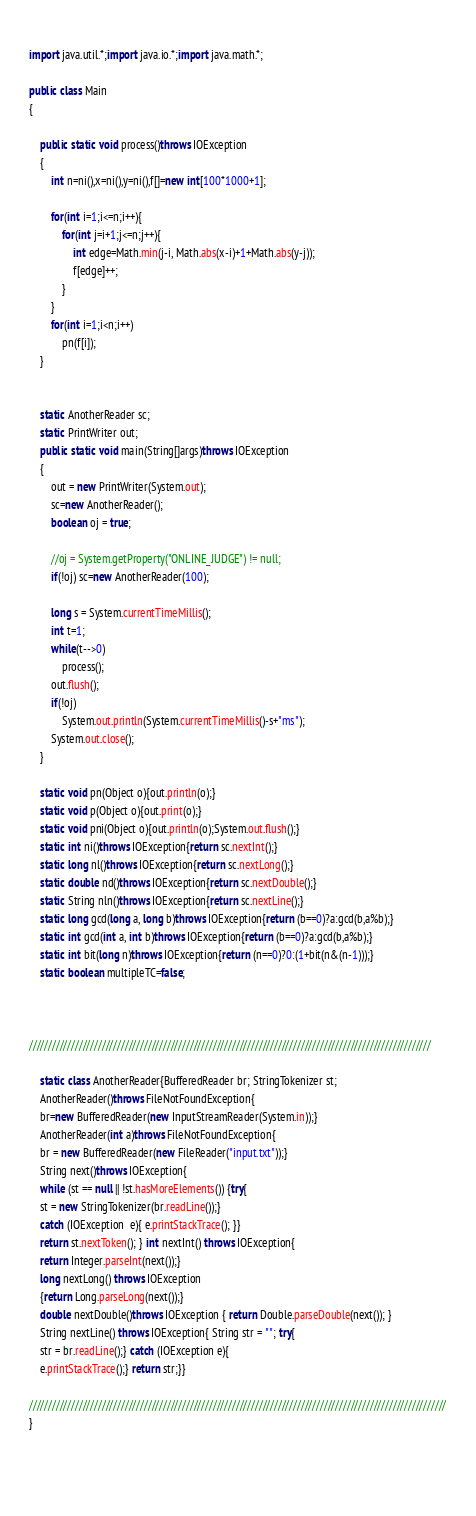<code> <loc_0><loc_0><loc_500><loc_500><_Java_>                
import java.util.*;import java.io.*;import java.math.*;

public class Main
{

    public static void process()throws IOException
    {
        int n=ni(),x=ni(),y=ni(),f[]=new int[100*1000+1];

        for(int i=1;i<=n;i++){
            for(int j=i+1;j<=n;j++){
                int edge=Math.min(j-i, Math.abs(x-i)+1+Math.abs(y-j));
                f[edge]++;
            }
        }
        for(int i=1;i<n;i++)
            pn(f[i]);
    }


    static AnotherReader sc;
    static PrintWriter out;
    public static void main(String[]args)throws IOException
    {
        out = new PrintWriter(System.out);
        sc=new AnotherReader();
        boolean oj = true;

        //oj = System.getProperty("ONLINE_JUDGE") != null;
        if(!oj) sc=new AnotherReader(100);

        long s = System.currentTimeMillis();
        int t=1;
        while(t-->0)
            process();
        out.flush();
        if(!oj)
            System.out.println(System.currentTimeMillis()-s+"ms");
        System.out.close();  
    }

    static void pn(Object o){out.println(o);}
    static void p(Object o){out.print(o);}
    static void pni(Object o){out.println(o);System.out.flush();}
    static int ni()throws IOException{return sc.nextInt();}
    static long nl()throws IOException{return sc.nextLong();}
    static double nd()throws IOException{return sc.nextDouble();}
    static String nln()throws IOException{return sc.nextLine();}
    static long gcd(long a, long b)throws IOException{return (b==0)?a:gcd(b,a%b);}
    static int gcd(int a, int b)throws IOException{return (b==0)?a:gcd(b,a%b);}
    static int bit(long n)throws IOException{return (n==0)?0:(1+bit(n&(n-1)));}
    static boolean multipleTC=false;



/////////////////////////////////////////////////////////////////////////////////////////////////////////

    static class AnotherReader{BufferedReader br; StringTokenizer st;
    AnotherReader()throws FileNotFoundException{
    br=new BufferedReader(new InputStreamReader(System.in));}
    AnotherReader(int a)throws FileNotFoundException{
    br = new BufferedReader(new FileReader("input.txt"));}
    String next()throws IOException{
    while (st == null || !st.hasMoreElements()) {try{
    st = new StringTokenizer(br.readLine());}
    catch (IOException  e){ e.printStackTrace(); }}
    return st.nextToken(); } int nextInt() throws IOException{
    return Integer.parseInt(next());}
    long nextLong() throws IOException
    {return Long.parseLong(next());}
    double nextDouble()throws IOException { return Double.parseDouble(next()); }
    String nextLine() throws IOException{ String str = ""; try{
    str = br.readLine();} catch (IOException e){
    e.printStackTrace();} return str;}}
    
/////////////////////////////////////////////////////////////////////////////////////////////////////////////
}
    
    
    </code> 